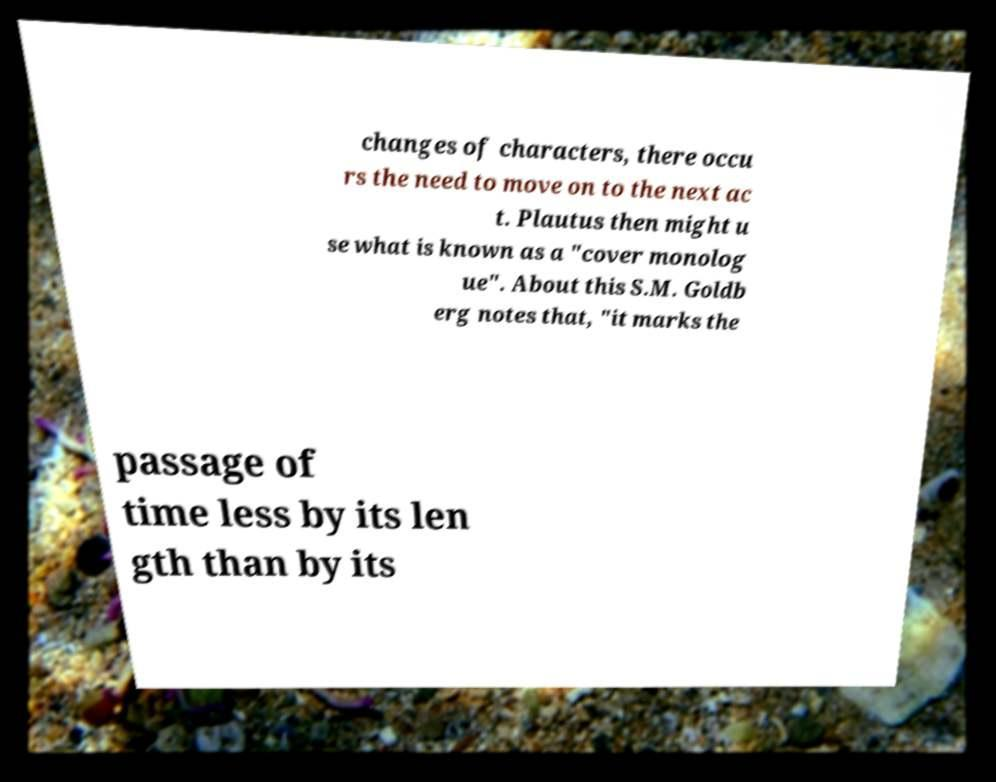There's text embedded in this image that I need extracted. Can you transcribe it verbatim? changes of characters, there occu rs the need to move on to the next ac t. Plautus then might u se what is known as a "cover monolog ue". About this S.M. Goldb erg notes that, "it marks the passage of time less by its len gth than by its 